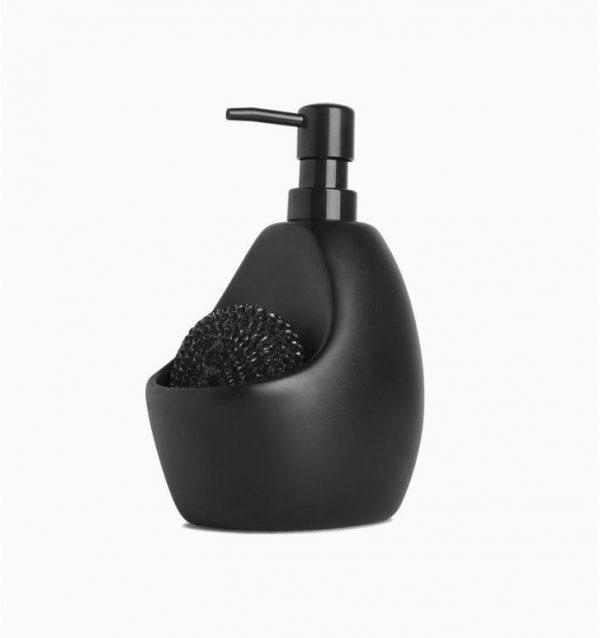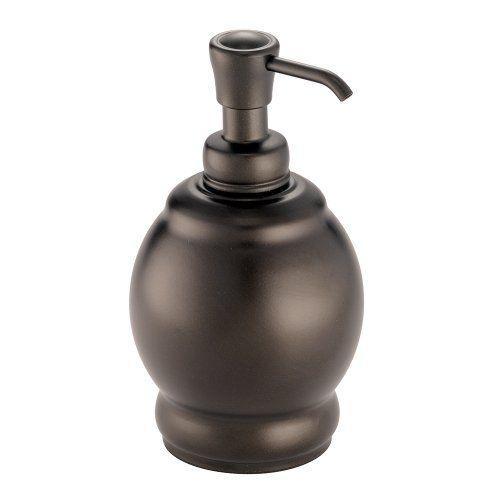The first image is the image on the left, the second image is the image on the right. Evaluate the accuracy of this statement regarding the images: "The right image contains a black dispenser with a chrome top.". Is it true? Answer yes or no. No. The first image is the image on the left, the second image is the image on the right. Evaluate the accuracy of this statement regarding the images: "The pump on one bottle has a spout that emerges horizontally, but then angles downward slightly, while the pump of the other bottle is horizontal with no angle.". Is it true? Answer yes or no. Yes. 